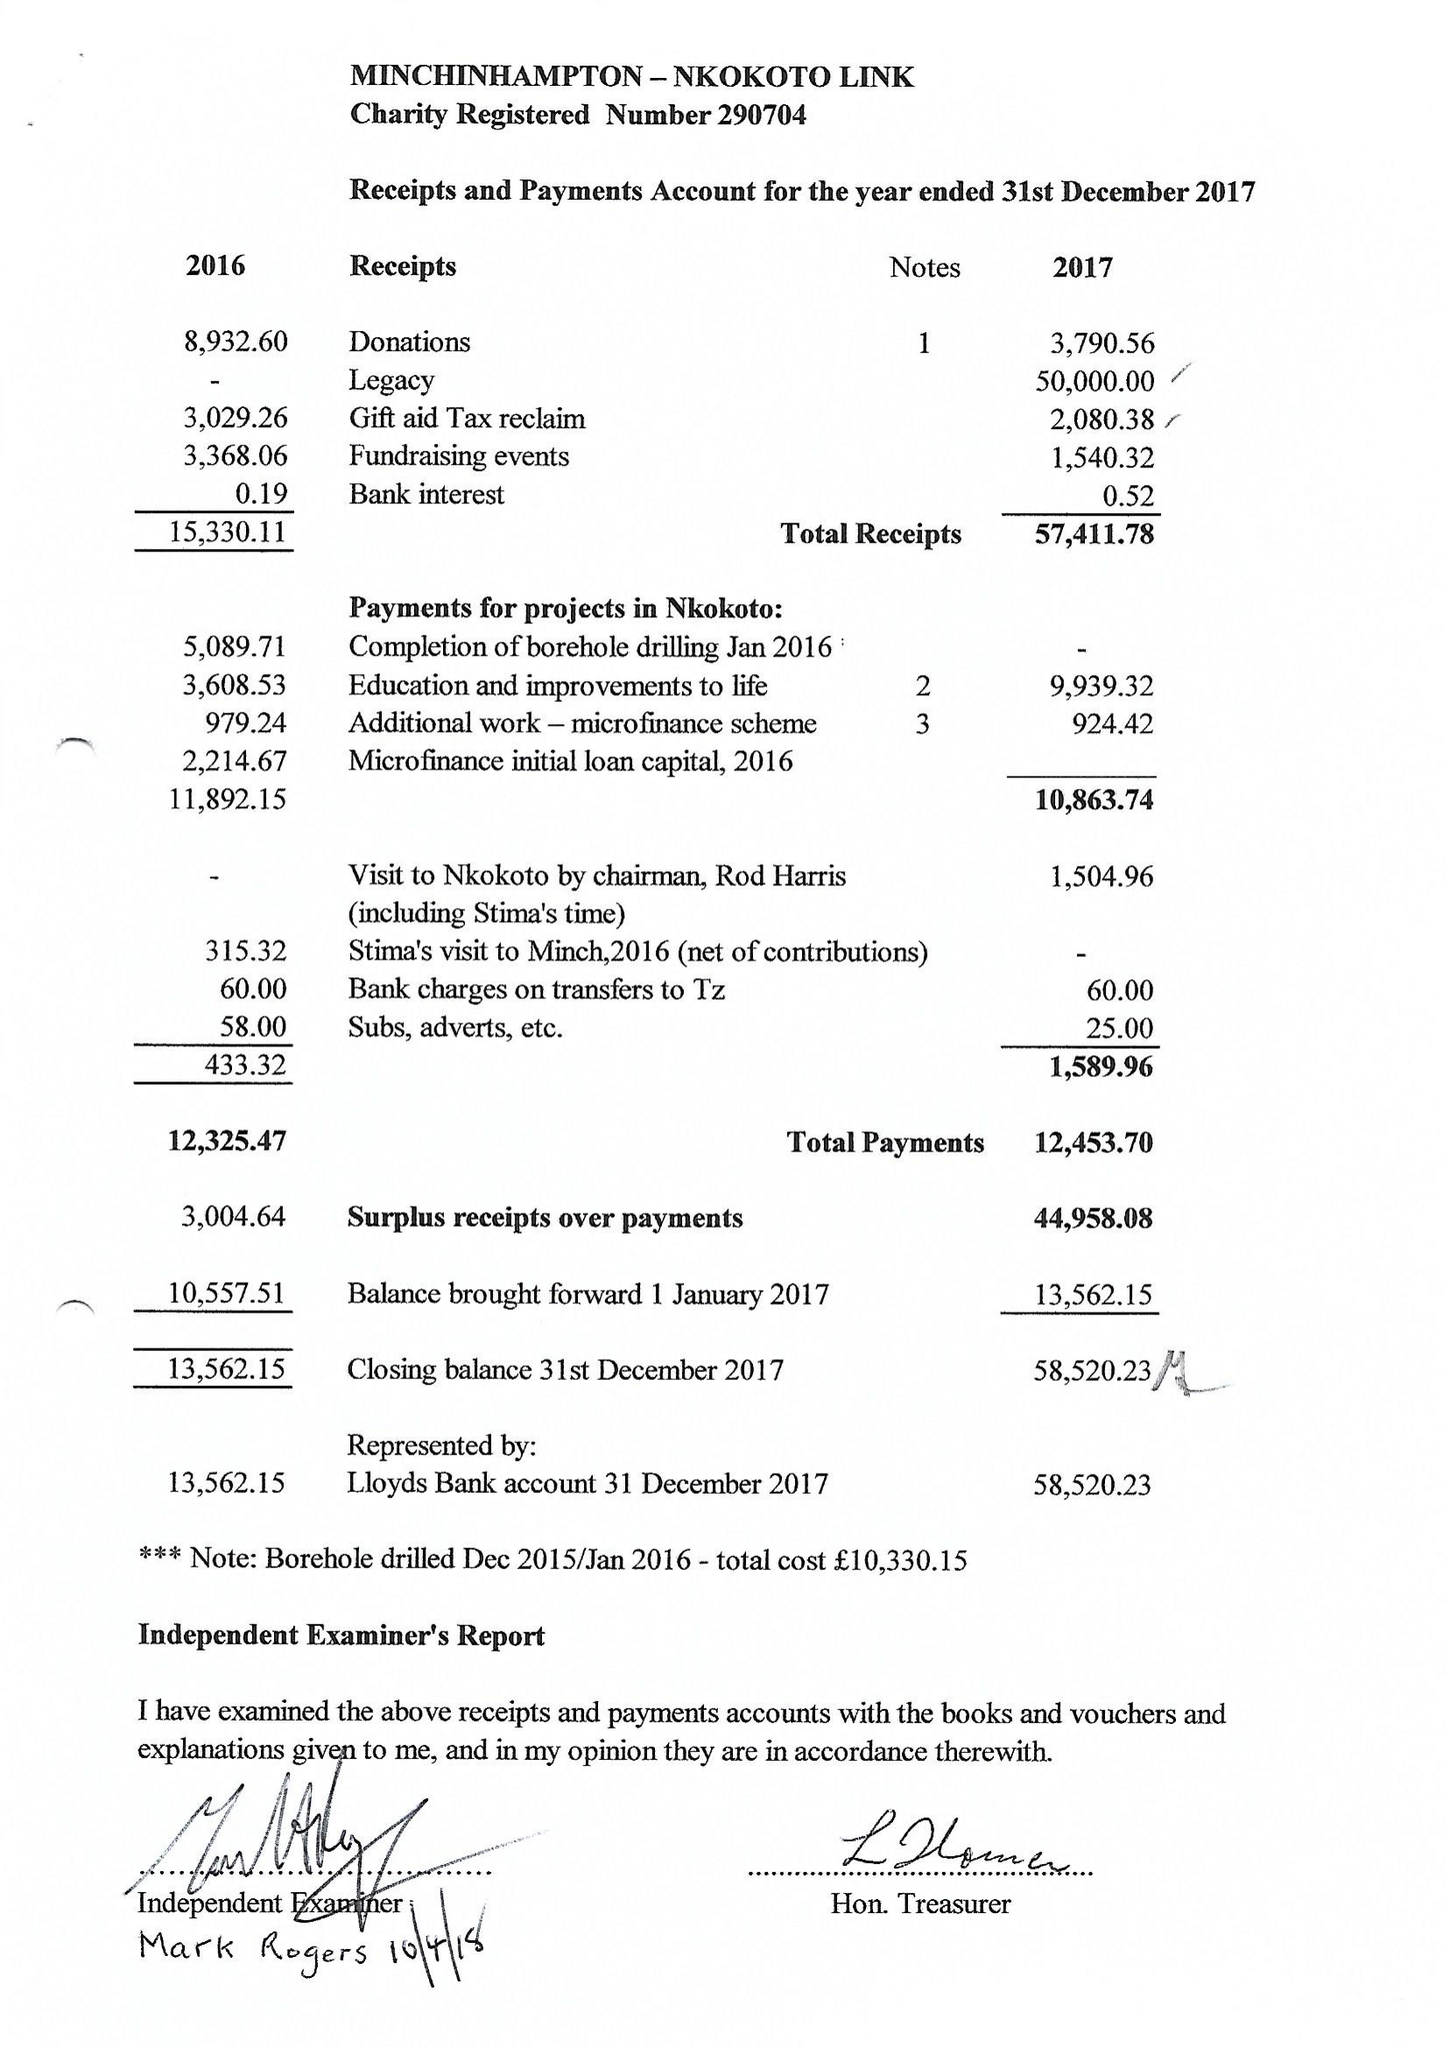What is the value for the address__street_line?
Answer the question using a single word or phrase. 4 SHEPPARD WAY 